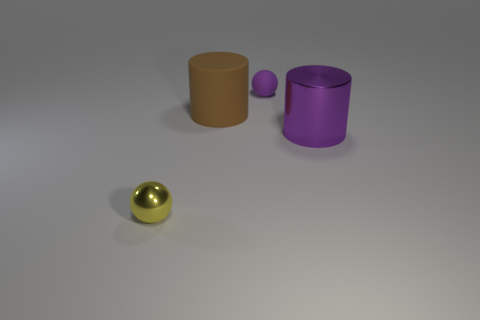What number of other objects are there of the same material as the tiny purple thing?
Offer a very short reply. 1. There is a purple object that is on the left side of the large purple metallic object; is its shape the same as the shiny object to the right of the metal sphere?
Keep it short and to the point. No. Does the big brown object have the same material as the small purple ball?
Give a very brief answer. Yes. What is the size of the sphere behind the metal object that is left of the metallic thing on the right side of the shiny ball?
Your response must be concise. Small. How many other things are there of the same color as the shiny ball?
Offer a very short reply. 0. There is another object that is the same size as the purple metal object; what shape is it?
Ensure brevity in your answer.  Cylinder. What number of tiny objects are green metal spheres or yellow metallic objects?
Provide a short and direct response. 1. There is a cylinder that is behind the cylinder in front of the big matte thing; are there any big purple cylinders that are on the right side of it?
Keep it short and to the point. Yes. Are there any yellow things that have the same size as the yellow sphere?
Offer a terse response. No. What material is the thing that is the same size as the purple sphere?
Your answer should be compact. Metal. 